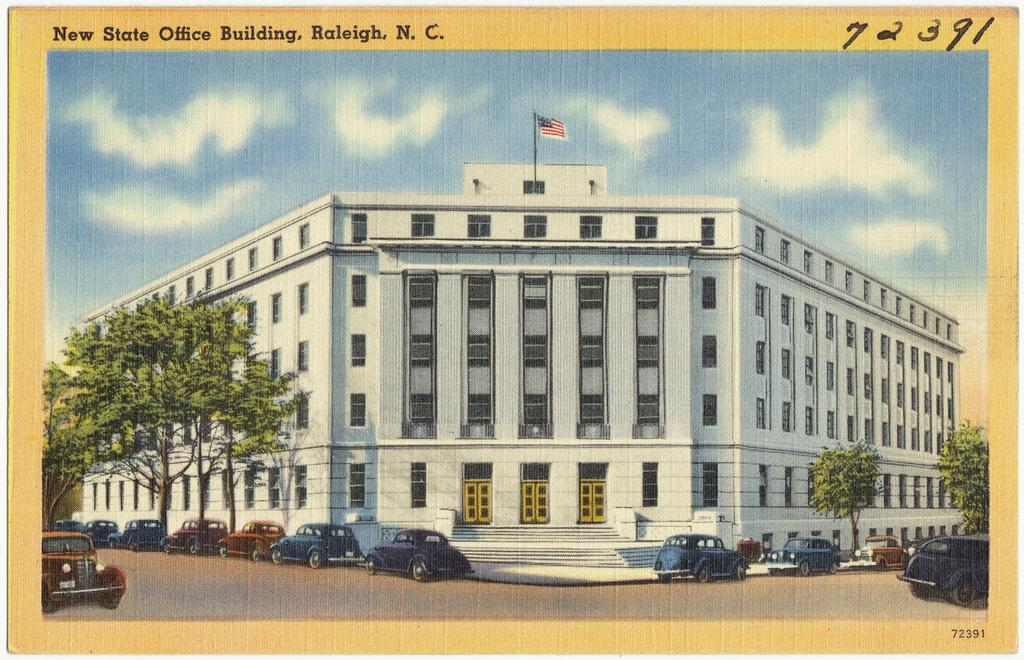Can you describe this image briefly? In this picture we can see cars on the road, trees, building with windows and doors, steps, flag and in the background we can see sky with clouds. 